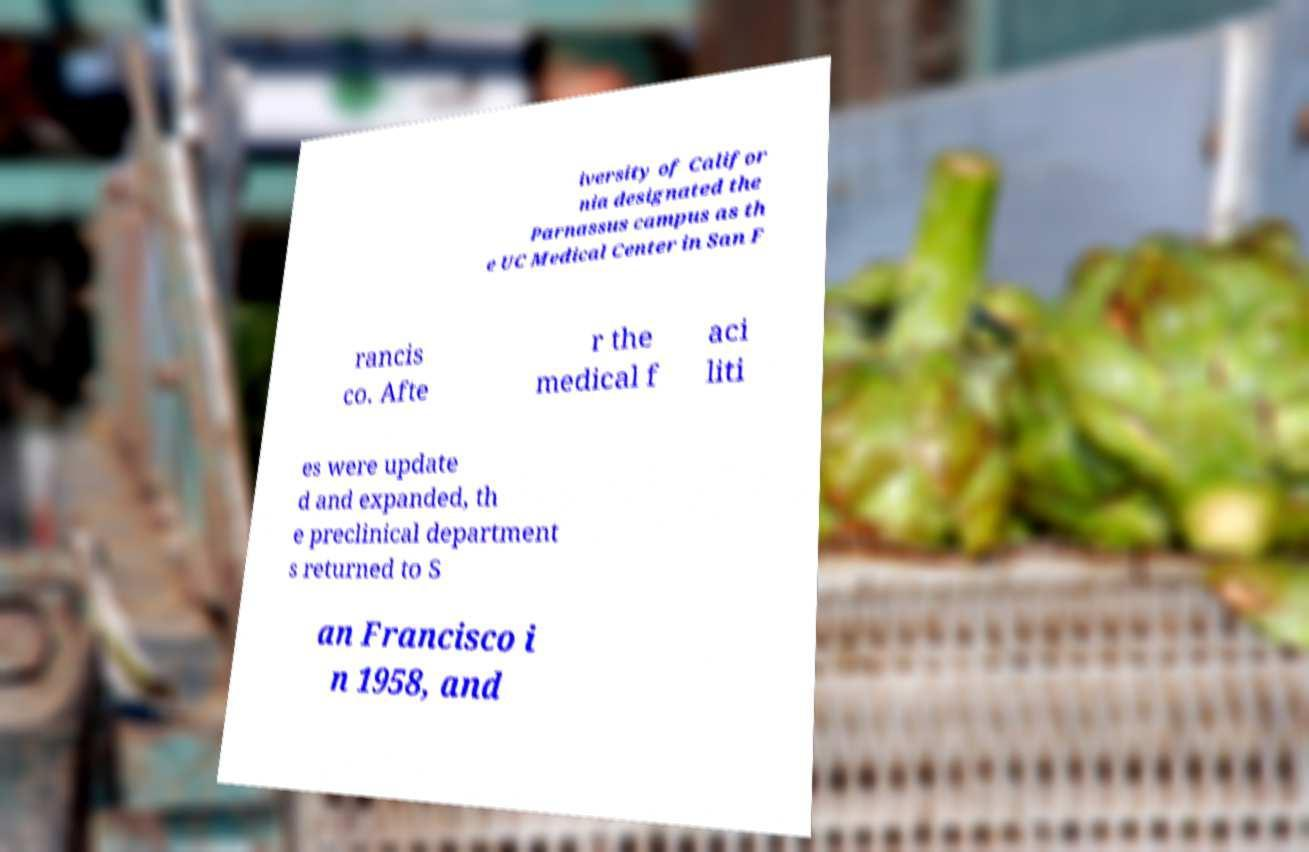I need the written content from this picture converted into text. Can you do that? iversity of Califor nia designated the Parnassus campus as th e UC Medical Center in San F rancis co. Afte r the medical f aci liti es were update d and expanded, th e preclinical department s returned to S an Francisco i n 1958, and 